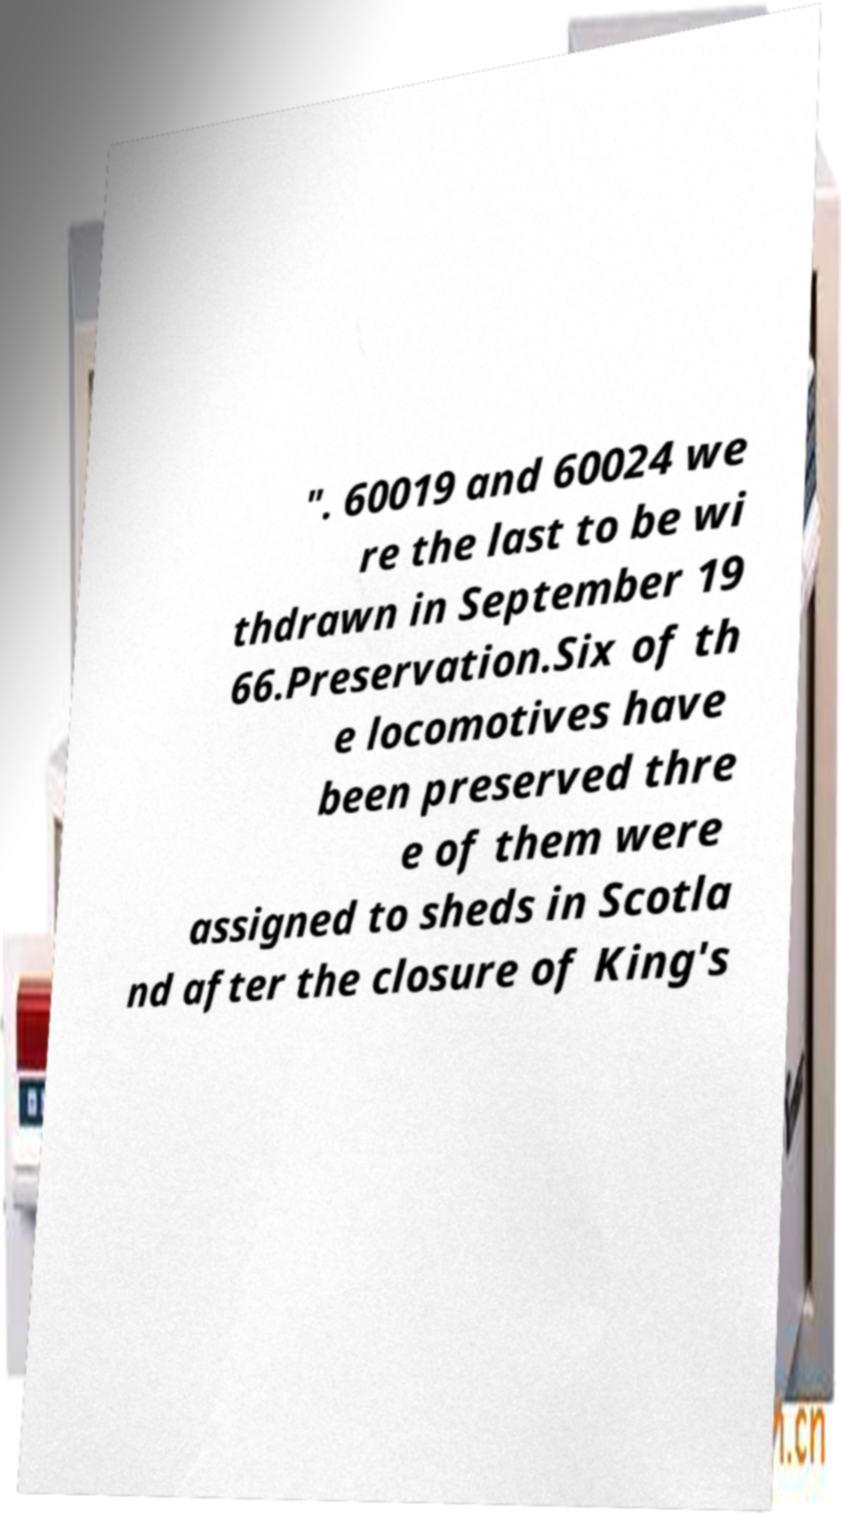There's text embedded in this image that I need extracted. Can you transcribe it verbatim? ". 60019 and 60024 we re the last to be wi thdrawn in September 19 66.Preservation.Six of th e locomotives have been preserved thre e of them were assigned to sheds in Scotla nd after the closure of King's 